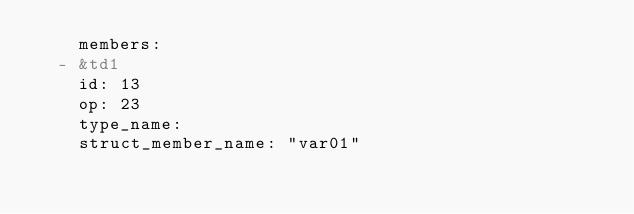<code> <loc_0><loc_0><loc_500><loc_500><_YAML_>    members:
  - &td1
    id: 13
    op: 23
    type_name: 
    struct_member_name: "var01"</code> 